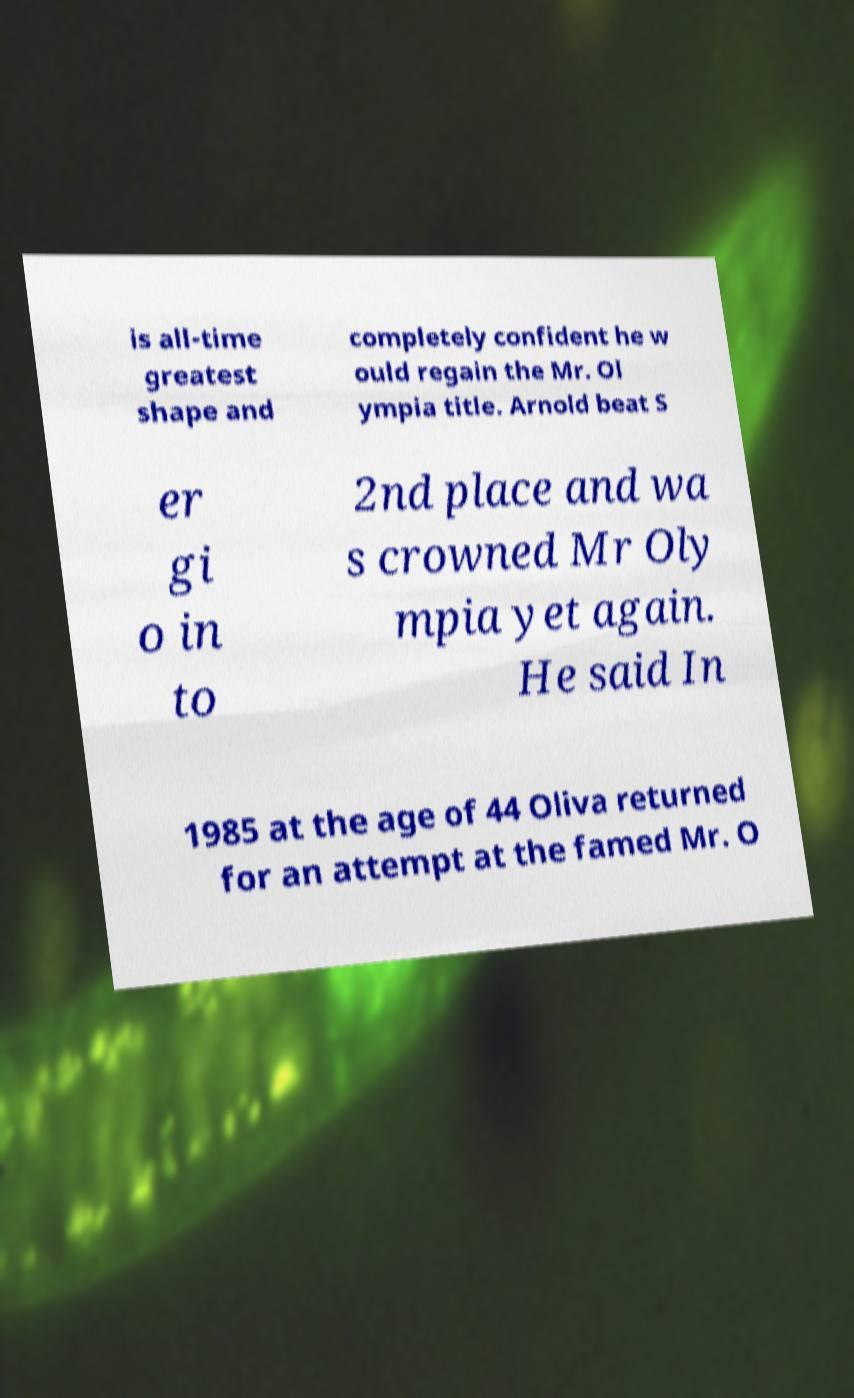What messages or text are displayed in this image? I need them in a readable, typed format. is all-time greatest shape and completely confident he w ould regain the Mr. Ol ympia title. Arnold beat S er gi o in to 2nd place and wa s crowned Mr Oly mpia yet again. He said In 1985 at the age of 44 Oliva returned for an attempt at the famed Mr. O 